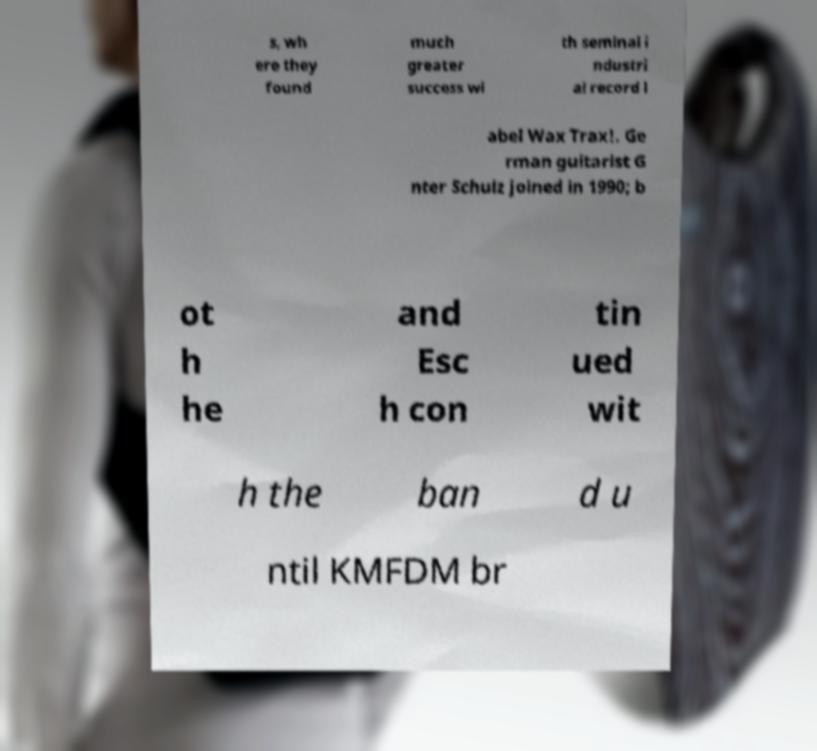Could you assist in decoding the text presented in this image and type it out clearly? s, wh ere they found much greater success wi th seminal i ndustri al record l abel Wax Trax!. Ge rman guitarist G nter Schulz joined in 1990; b ot h he and Esc h con tin ued wit h the ban d u ntil KMFDM br 